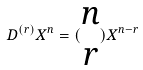<formula> <loc_0><loc_0><loc_500><loc_500>D ^ { ( r ) } X ^ { n } = ( \begin{matrix} n \\ r \end{matrix} ) X ^ { n - r }</formula> 